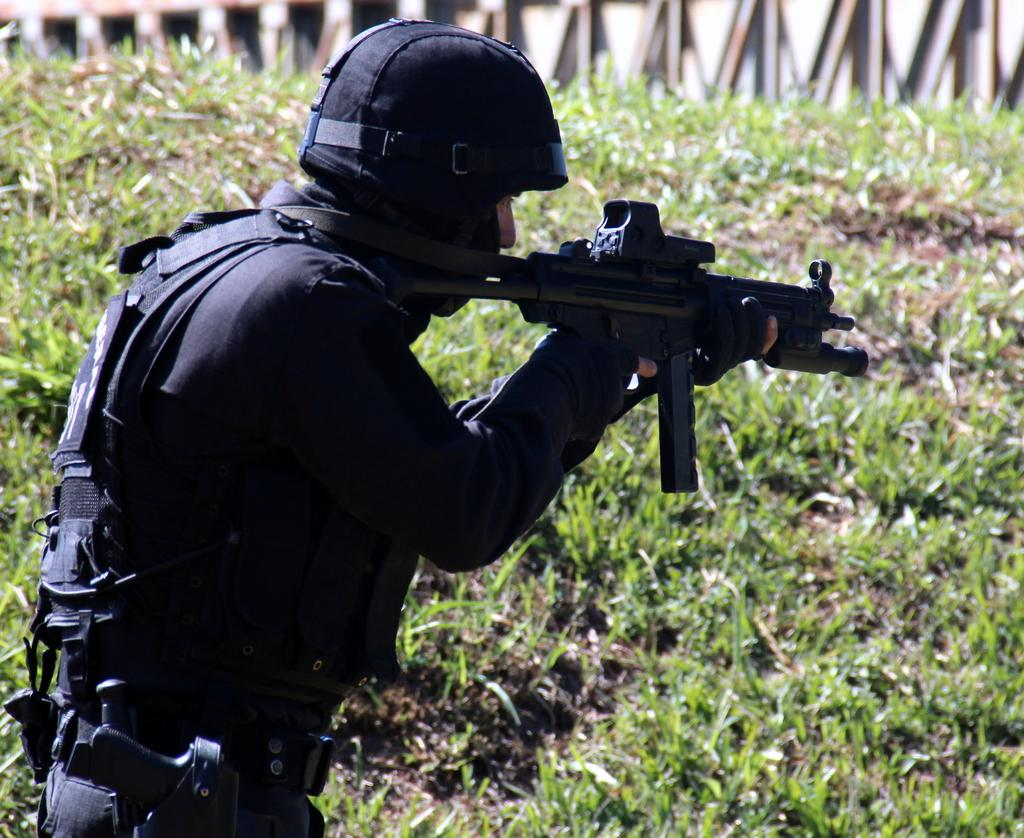What is the main subject of the image? There is a person in the image. What is the person wearing? The person is wearing a black dress and a black helmet. What object is the person holding? The person is holding a gun. What can be seen in the background of the image? There is a grassland and a bridge in the background of the image. What type of flower is the monkey holding in the image? There is no monkey or flower present in the image. What educational institution can be seen in the background of the image? There is no educational institution visible in the image; it features a grassland and a bridge in the background. 